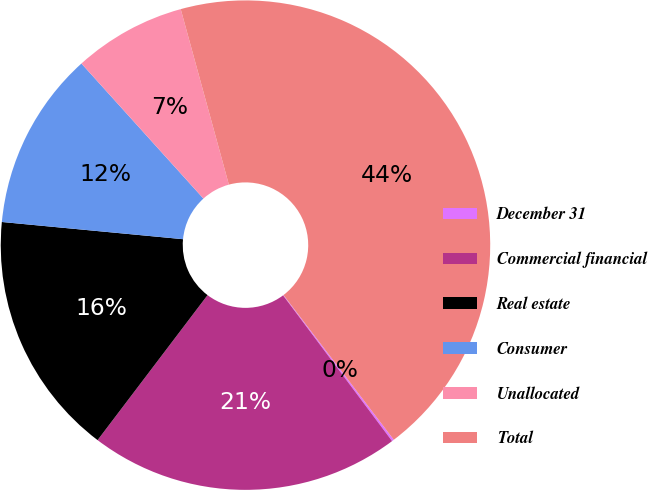Convert chart to OTSL. <chart><loc_0><loc_0><loc_500><loc_500><pie_chart><fcel>December 31<fcel>Commercial financial<fcel>Real estate<fcel>Consumer<fcel>Unallocated<fcel>Total<nl><fcel>0.14%<fcel>20.55%<fcel>16.18%<fcel>11.8%<fcel>7.43%<fcel>43.9%<nl></chart> 